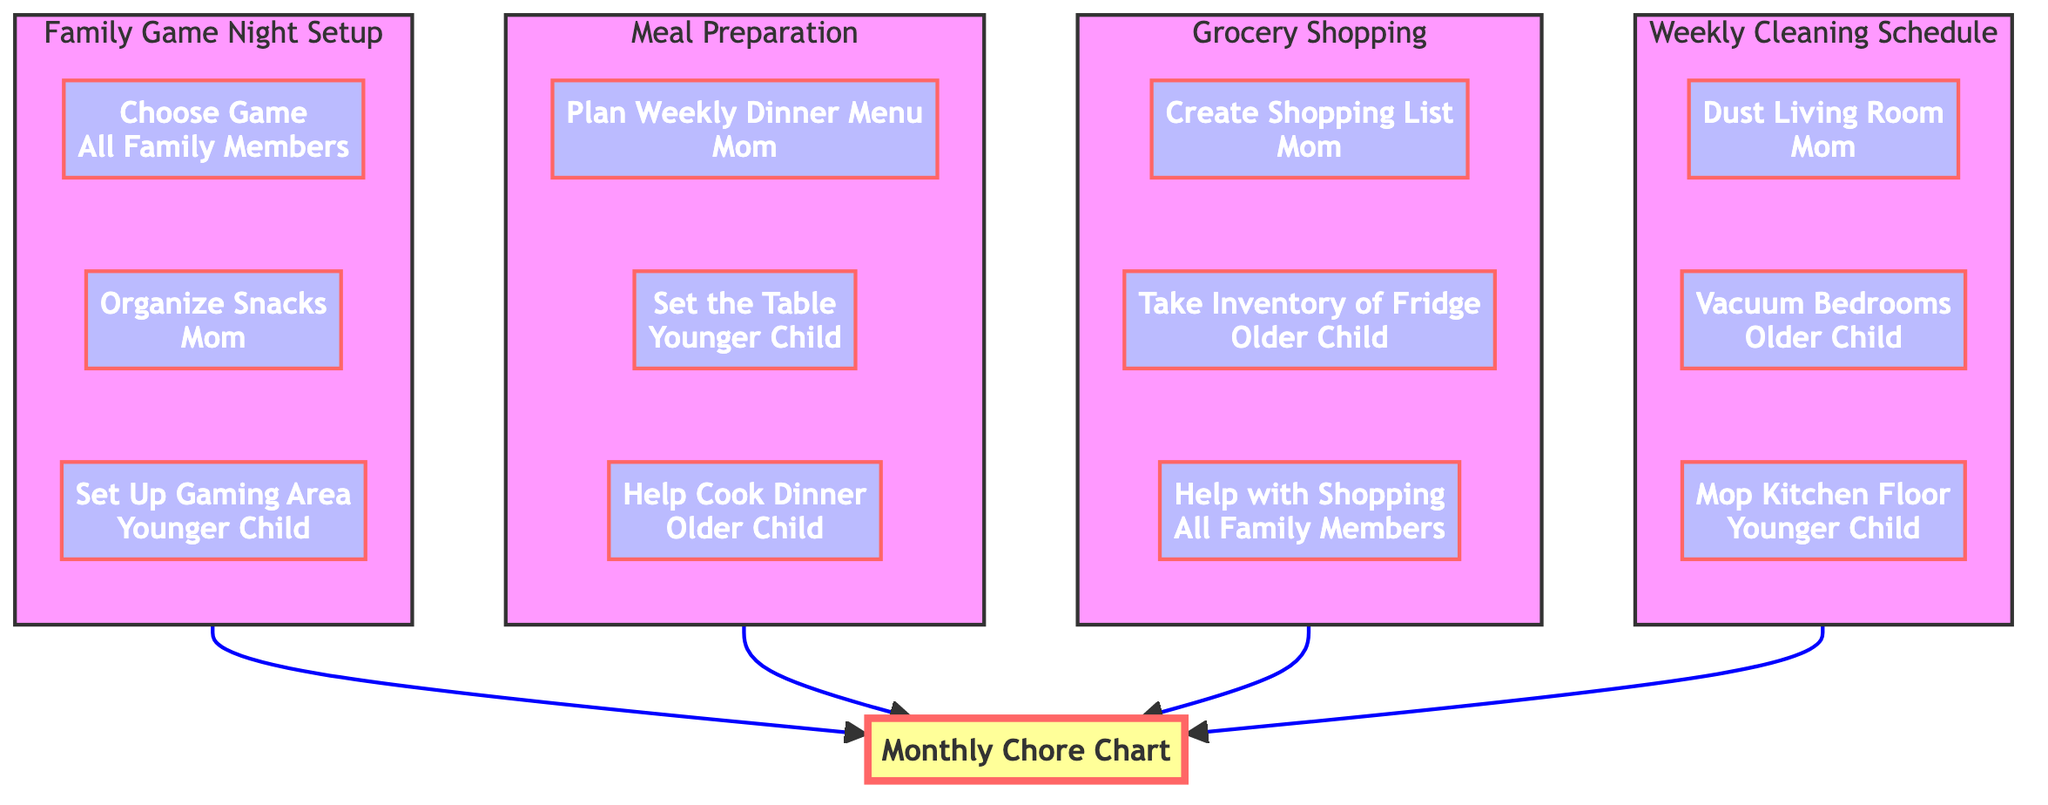What's the total number of tasks in the Monthly Chore Chart? The chart contains four main elements: Weekly Cleaning Schedule, Grocery Shopping, Meal Preparation, and Family Game Night Setup. Each of these elements has three tasks associated with it, resulting in a total of 4 elements × 3 tasks = 12 tasks overall.
Answer: 12 Who is responsible for organizing snacks during Family Game Night? The task of organizing snacks is assigned to Mom, as indicated in the Family Game Night Setup section of the chart.
Answer: Mom How many tasks are assigned to the Younger Child? The Younger Child has three tasks assigned: Mop Kitchen Floor in Weekly Cleaning Schedule, Set the Table in Meal Preparation, and Set Up Gaming Area in Family Game Night Setup. Thus, the Younger Child has a total of 3 tasks.
Answer: 3 Which family member is responsible for helping with shopping? The task of helping with shopping is assigned to All Family Members, indicating that everyone in the family is responsible for this task.
Answer: All Family Members What is the primary task for Mom in Grocery Shopping? The primary task assigned to Mom in Grocery Shopping is to create the shopping list, as specified in the chart.
Answer: Create Shopping List In which subgraph is the task "Help Cook Dinner" located? The task "Help Cook Dinner" can be found in the Meal Preparation subgraph, indicating it is related to preparing meals for the family.
Answer: Meal Preparation How many different elements are depicted in the diagram? The diagram shows four distinct elements: Weekly Cleaning Schedule, Grocery Shopping, Meal Preparation, and Family Game Night Setup, which adds up to a total of 4 elements.
Answer: 4 Which task does the Older Child have in the Weekly Cleaning Schedule? The Older Child is assigned the task of vacuuming bedrooms in the Weekly Cleaning Schedule section of the diagram.
Answer: Vacuum Bedrooms What task is the first one listed under Meal Preparation? The first task listed under Meal Preparation is planning the weekly dinner menu, which is assigned to Mom.
Answer: Plan Weekly Dinner Menu 